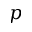Convert formula to latex. <formula><loc_0><loc_0><loc_500><loc_500>p</formula> 